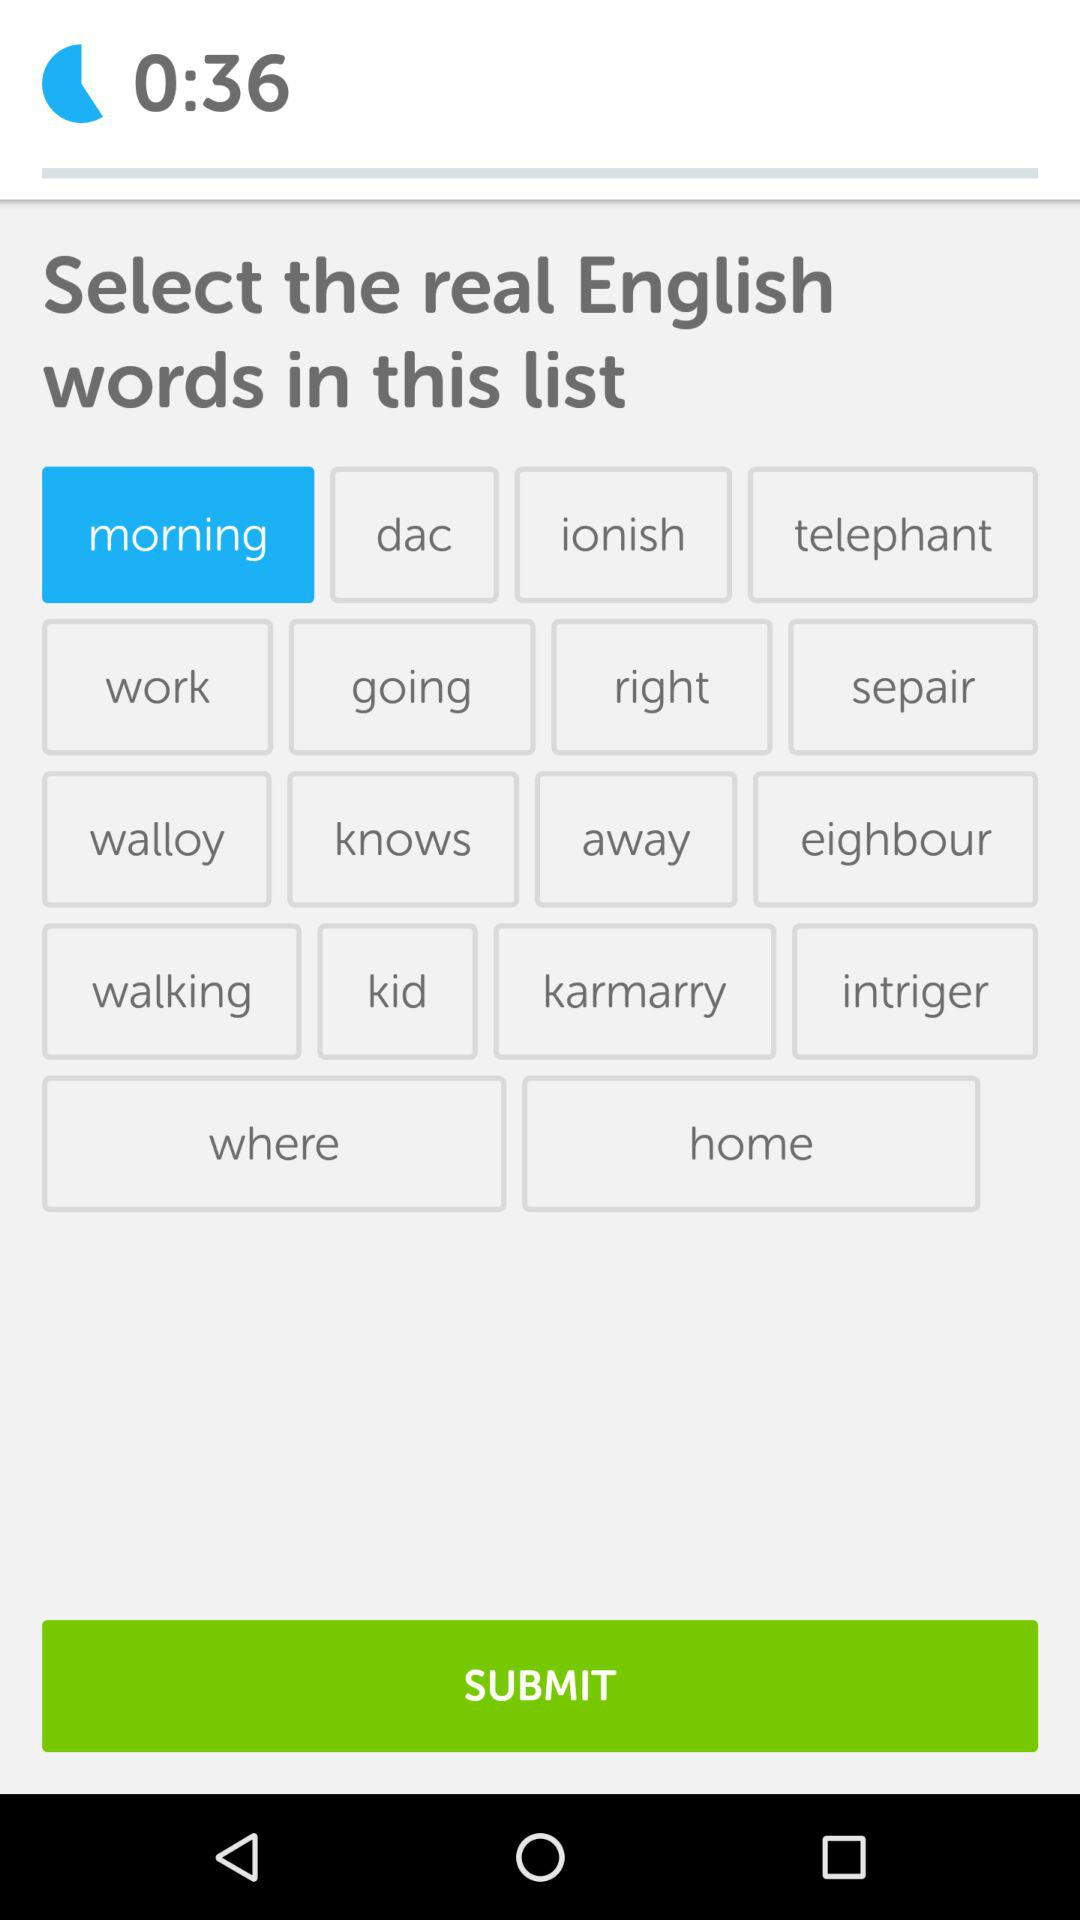Which English word was selected? The selected English word was "morning". 